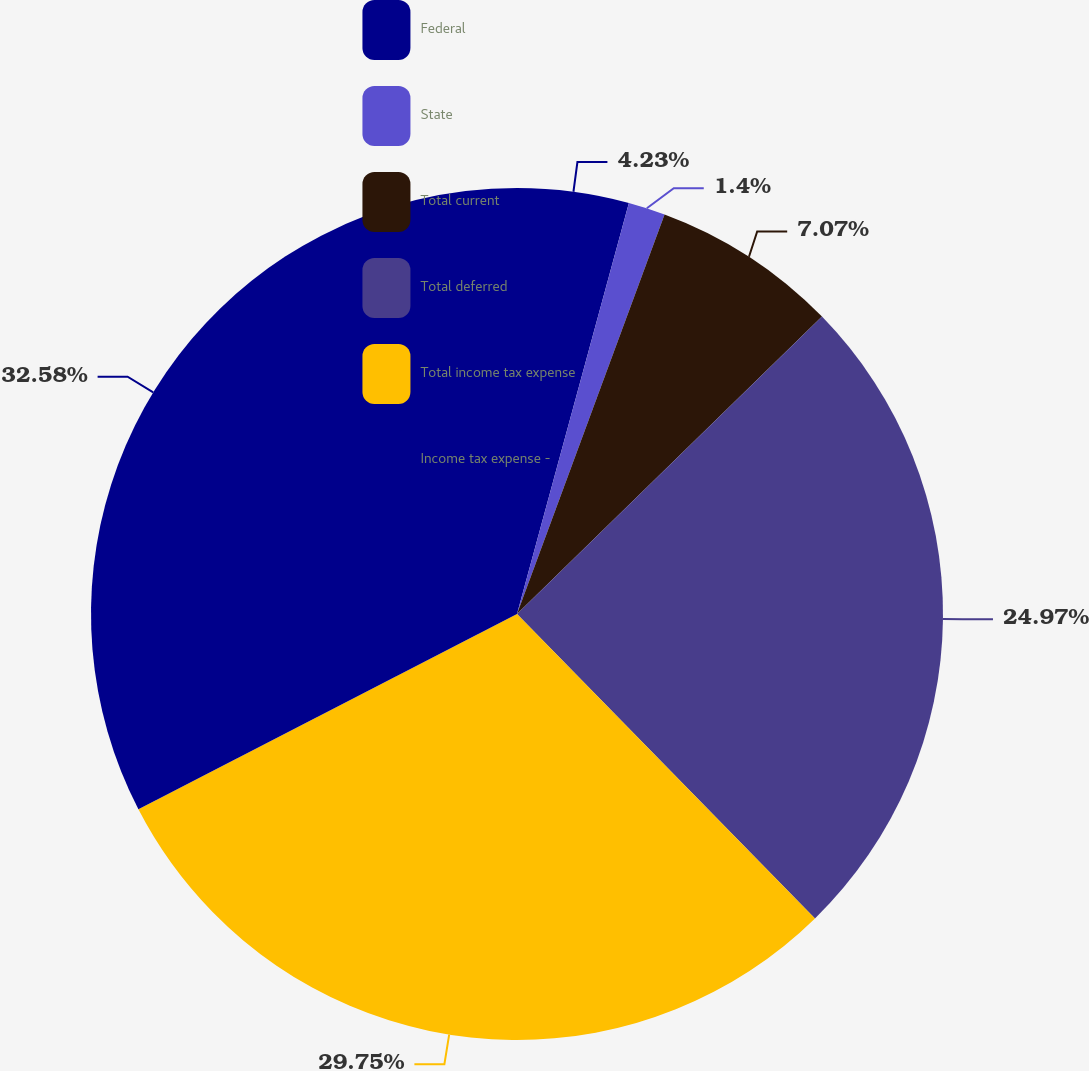Convert chart. <chart><loc_0><loc_0><loc_500><loc_500><pie_chart><fcel>Federal<fcel>State<fcel>Total current<fcel>Total deferred<fcel>Total income tax expense<fcel>Income tax expense -<nl><fcel>4.23%<fcel>1.4%<fcel>7.07%<fcel>24.97%<fcel>29.75%<fcel>32.58%<nl></chart> 